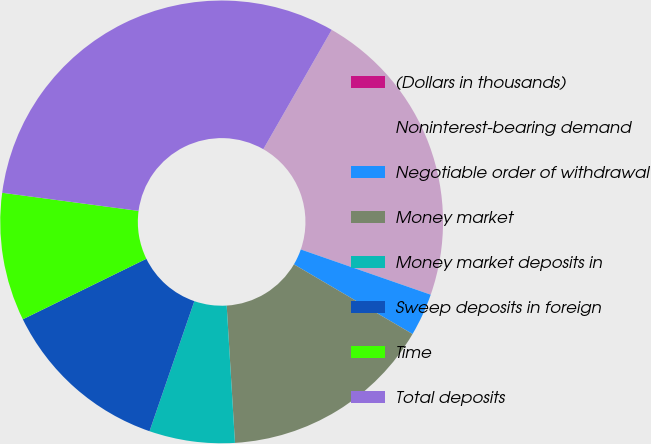Convert chart to OTSL. <chart><loc_0><loc_0><loc_500><loc_500><pie_chart><fcel>(Dollars in thousands)<fcel>Noninterest-bearing demand<fcel>Negotiable order of withdrawal<fcel>Money market<fcel>Money market deposits in<fcel>Sweep deposits in foreign<fcel>Time<fcel>Total deposits<nl><fcel>0.0%<fcel>22.05%<fcel>3.12%<fcel>15.59%<fcel>6.24%<fcel>12.47%<fcel>9.35%<fcel>31.18%<nl></chart> 